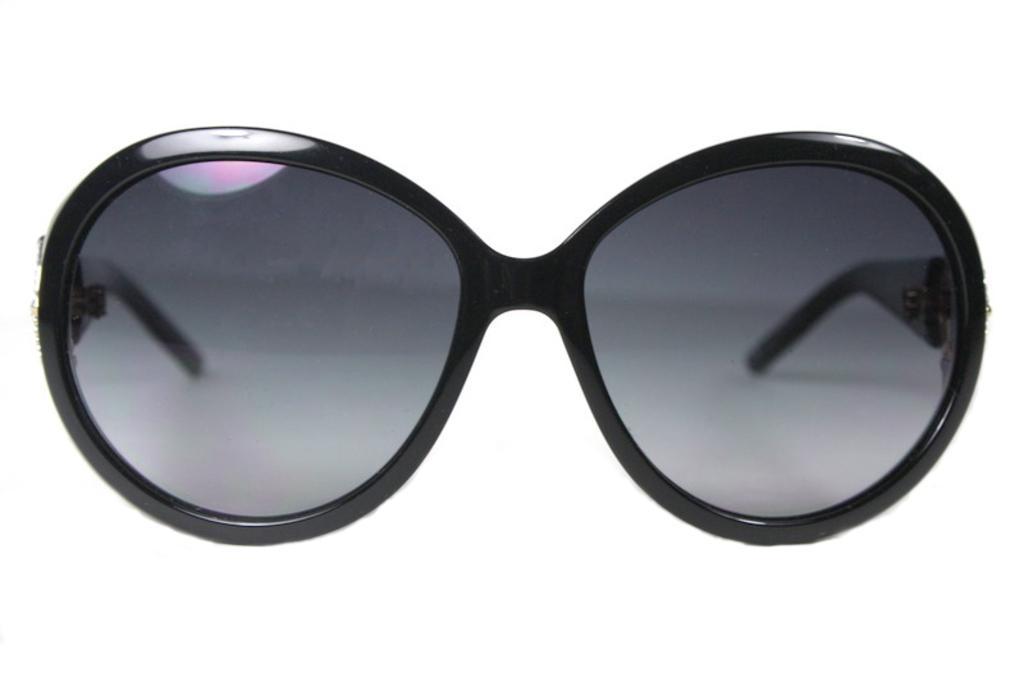Describe this image in one or two sentences. In this picture we can see goggles on the white surface. In the background of the image it is white. 